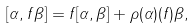<formula> <loc_0><loc_0><loc_500><loc_500>[ \alpha , f \beta ] = f [ \alpha , \beta ] + \rho ( \alpha ) ( f ) \beta ,</formula> 